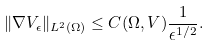Convert formula to latex. <formula><loc_0><loc_0><loc_500><loc_500>\| \nabla V _ { \epsilon } \| _ { L ^ { 2 } ( \Omega ) } \leq C ( \Omega , V ) \frac { 1 } { \epsilon ^ { 1 / 2 } } .</formula> 